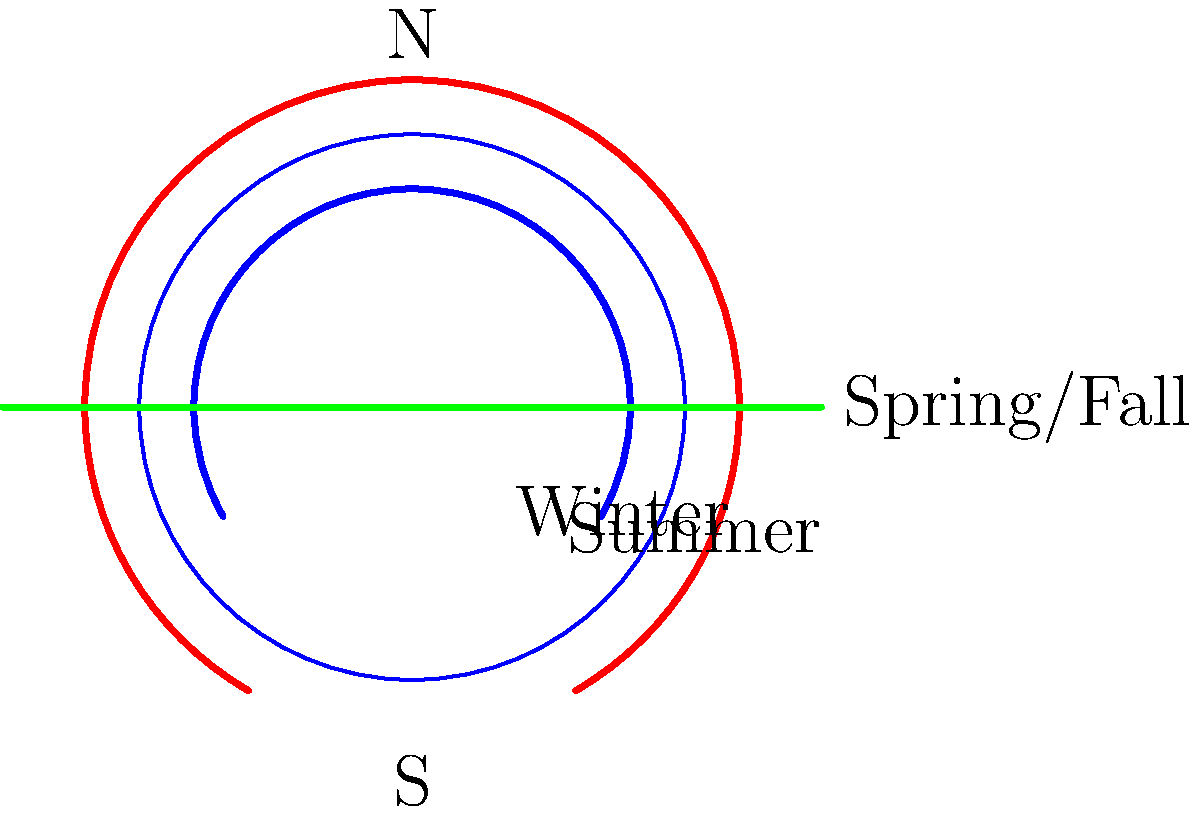As an HR manager trying to fill positions in your tech company, you've come across a candidate with an astronomy background. To assess their knowledge, you ask: What is the primary reason for the Sun's apparent path across the sky changing between summer and winter, as illustrated in the diagram? To understand the changing apparent path of the Sun across the sky, we need to consider the following steps:

1. Earth's axis tilt: The Earth's rotational axis is tilted at an angle of approximately 23.5° relative to its orbital plane around the Sun.

2. Earth's revolution: As the Earth orbits the Sun, this tilt remains constant, always pointing in the same direction in space.

3. Seasonal changes: Due to this tilt and the Earth's revolution, different parts of the Earth receive varying amounts of sunlight throughout the year.

4. Summer solstice: In summer (for the Northern Hemisphere), the North Pole is tilted towards the Sun. This causes:
   a) The Sun to appear higher in the sky
   b) A longer arc of the Sun's path across the sky
   c) Longer daylight hours

5. Winter solstice: In winter (for the Northern Hemisphere), the North Pole is tilted away from the Sun. This results in:
   a) The Sun appearing lower in the sky
   b) A shorter arc of the Sun's path across the sky
   c) Shorter daylight hours

6. Equinoxes: During spring and fall equinoxes, the Earth's axis is perpendicular to the Sun's rays, resulting in equal day and night lengths, and the Sun's path appears midway between the summer and winter paths.

The primary reason for these changes is not the Earth's distance from the Sun (which does vary slightly due to the elliptical orbit), but rather the tilt of the Earth's axis and its position in its orbit around the Sun.
Answer: The Earth's axial tilt and its orbital position around the Sun. 